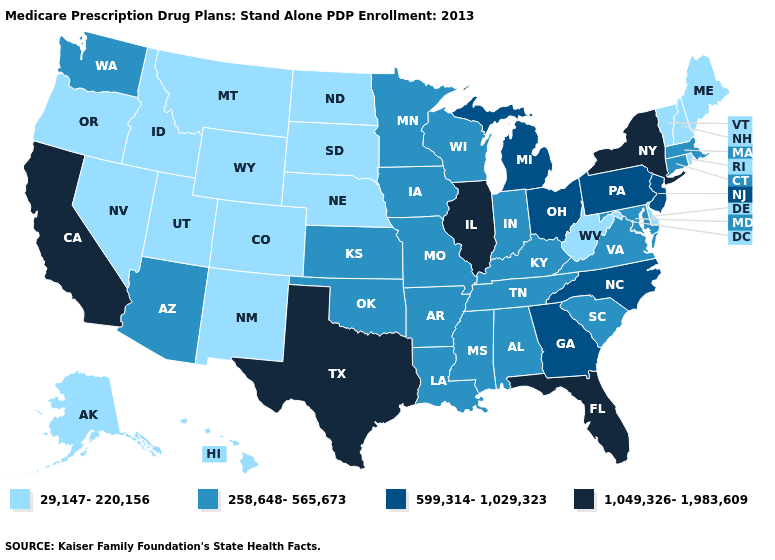Name the states that have a value in the range 1,049,326-1,983,609?
Short answer required. California, Florida, Illinois, New York, Texas. Name the states that have a value in the range 258,648-565,673?
Short answer required. Alabama, Arkansas, Arizona, Connecticut, Iowa, Indiana, Kansas, Kentucky, Louisiana, Massachusetts, Maryland, Minnesota, Missouri, Mississippi, Oklahoma, South Carolina, Tennessee, Virginia, Washington, Wisconsin. How many symbols are there in the legend?
Concise answer only. 4. What is the lowest value in states that border Mississippi?
Answer briefly. 258,648-565,673. Does Delaware have the lowest value in the South?
Concise answer only. Yes. What is the lowest value in states that border Louisiana?
Short answer required. 258,648-565,673. Does the map have missing data?
Short answer required. No. Which states have the lowest value in the USA?
Give a very brief answer. Alaska, Colorado, Delaware, Hawaii, Idaho, Maine, Montana, North Dakota, Nebraska, New Hampshire, New Mexico, Nevada, Oregon, Rhode Island, South Dakota, Utah, Vermont, West Virginia, Wyoming. What is the value of Indiana?
Be succinct. 258,648-565,673. Which states have the lowest value in the MidWest?
Answer briefly. North Dakota, Nebraska, South Dakota. Name the states that have a value in the range 29,147-220,156?
Concise answer only. Alaska, Colorado, Delaware, Hawaii, Idaho, Maine, Montana, North Dakota, Nebraska, New Hampshire, New Mexico, Nevada, Oregon, Rhode Island, South Dakota, Utah, Vermont, West Virginia, Wyoming. What is the value of Minnesota?
Keep it brief. 258,648-565,673. Does New Hampshire have the highest value in the Northeast?
Give a very brief answer. No. What is the lowest value in the USA?
Give a very brief answer. 29,147-220,156. Name the states that have a value in the range 29,147-220,156?
Concise answer only. Alaska, Colorado, Delaware, Hawaii, Idaho, Maine, Montana, North Dakota, Nebraska, New Hampshire, New Mexico, Nevada, Oregon, Rhode Island, South Dakota, Utah, Vermont, West Virginia, Wyoming. 